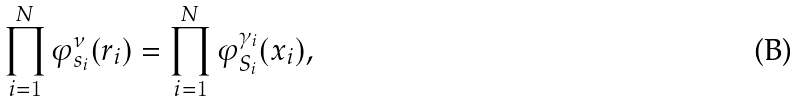Convert formula to latex. <formula><loc_0><loc_0><loc_500><loc_500>\prod _ { i = 1 } ^ { N } \varphi _ { { s } _ { i } } ^ { \nu } ( { r } _ { i } ) = \prod _ { i = 1 } ^ { N } \varphi _ { { S } _ { i } } ^ { \gamma _ { i } } ( { x } _ { i } ) ,</formula> 